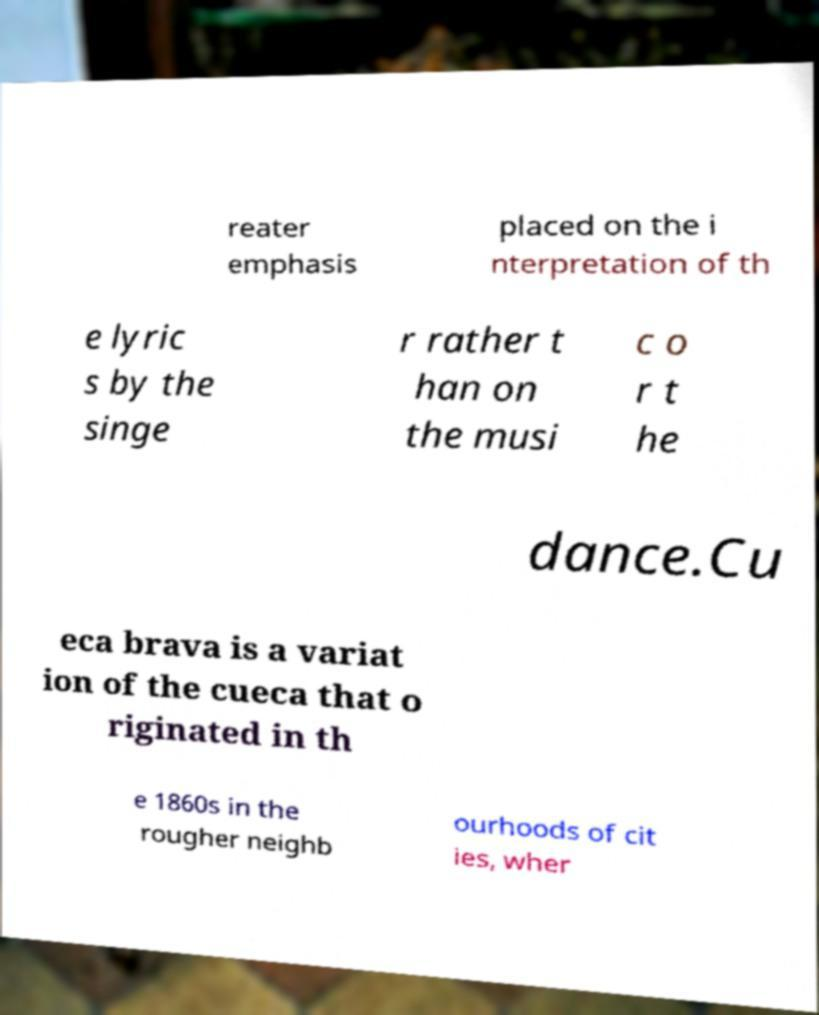Please identify and transcribe the text found in this image. reater emphasis placed on the i nterpretation of th e lyric s by the singe r rather t han on the musi c o r t he dance.Cu eca brava is a variat ion of the cueca that o riginated in th e 1860s in the rougher neighb ourhoods of cit ies, wher 